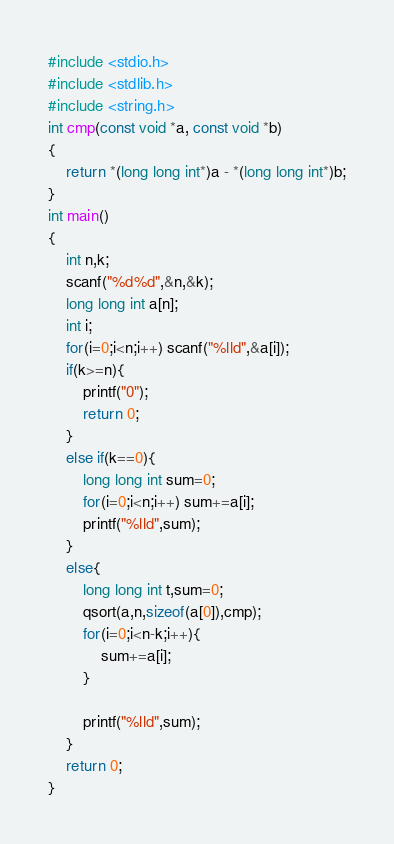Convert code to text. <code><loc_0><loc_0><loc_500><loc_500><_C_>#include <stdio.h>
#include <stdlib.h>
#include <string.h>
int cmp(const void *a, const void *b)
{
    return *(long long int*)a - *(long long int*)b;
}
int main()
{
	int n,k;
	scanf("%d%d",&n,&k);
	long long int a[n];
	int i;
	for(i=0;i<n;i++) scanf("%lld",&a[i]);
	if(k>=n){
		printf("0");
		return 0;
	}
	else if(k==0){
		long long int sum=0;
		for(i=0;i<n;i++) sum+=a[i];
		printf("%lld",sum);
	}
	else{
		long long int t,sum=0;
		qsort(a,n,sizeof(a[0]),cmp);
		for(i=0;i<n-k;i++){
			sum+=a[i];
		}
		
		printf("%lld",sum);
	}
	return 0;
}</code> 